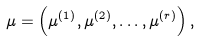Convert formula to latex. <formula><loc_0><loc_0><loc_500><loc_500>\mu = \left ( \mu ^ { ( 1 ) } , \mu ^ { ( 2 ) } , \dots , \mu ^ { ( r ) } \right ) ,</formula> 